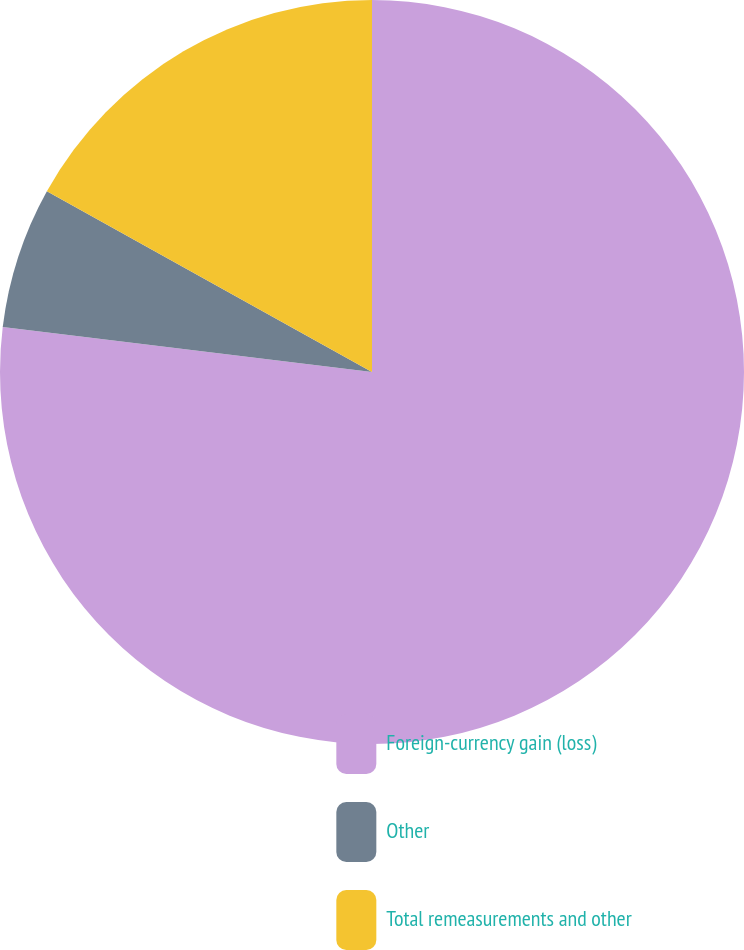Convert chart. <chart><loc_0><loc_0><loc_500><loc_500><pie_chart><fcel>Foreign-currency gain (loss)<fcel>Other<fcel>Total remeasurements and other<nl><fcel>76.92%<fcel>6.15%<fcel>16.92%<nl></chart> 